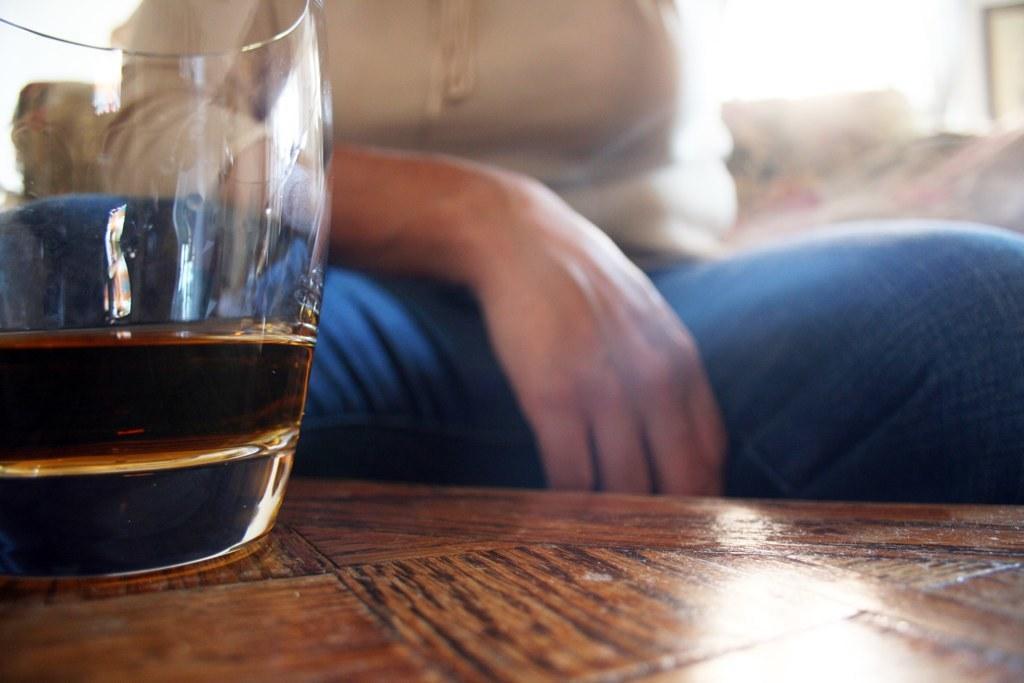Please provide a concise description of this image. On the left side of this image I can see a wine glass which is placed on the table. Behind this table a person is sitting. 